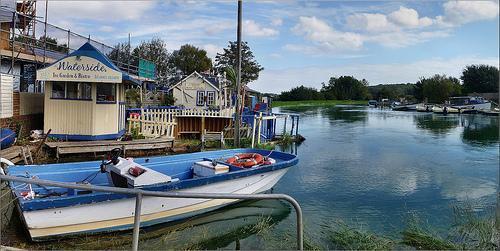How many boats are parked on the left side?
Give a very brief answer. 1. How many houses are there in the picture?
Give a very brief answer. 2. 